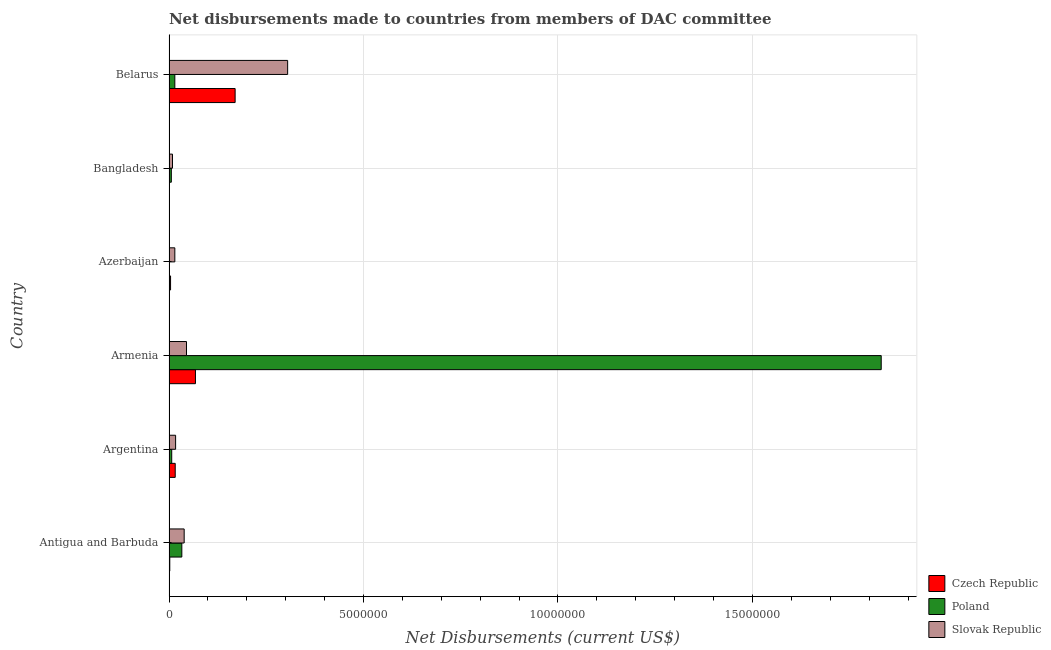Are the number of bars per tick equal to the number of legend labels?
Ensure brevity in your answer.  Yes. How many bars are there on the 6th tick from the top?
Ensure brevity in your answer.  3. How many bars are there on the 3rd tick from the bottom?
Make the answer very short. 3. What is the label of the 1st group of bars from the top?
Make the answer very short. Belarus. In how many cases, is the number of bars for a given country not equal to the number of legend labels?
Keep it short and to the point. 0. What is the net disbursements made by slovak republic in Belarus?
Provide a short and direct response. 3.05e+06. Across all countries, what is the maximum net disbursements made by slovak republic?
Your answer should be compact. 3.05e+06. Across all countries, what is the minimum net disbursements made by poland?
Offer a very short reply. 10000. In which country was the net disbursements made by poland maximum?
Your response must be concise. Armenia. In which country was the net disbursements made by slovak republic minimum?
Your response must be concise. Bangladesh. What is the total net disbursements made by czech republic in the graph?
Make the answer very short. 2.61e+06. What is the difference between the net disbursements made by poland in Bangladesh and that in Belarus?
Offer a terse response. -9.00e+04. What is the difference between the net disbursements made by poland in Antigua and Barbuda and the net disbursements made by czech republic in Armenia?
Your answer should be very brief. -3.50e+05. What is the average net disbursements made by czech republic per country?
Keep it short and to the point. 4.35e+05. What is the difference between the net disbursements made by czech republic and net disbursements made by slovak republic in Antigua and Barbuda?
Provide a short and direct response. -3.70e+05. In how many countries, is the net disbursements made by poland greater than 2000000 US$?
Offer a very short reply. 1. What is the ratio of the net disbursements made by poland in Azerbaijan to that in Belarus?
Provide a succinct answer. 0.07. Is the net disbursements made by czech republic in Antigua and Barbuda less than that in Bangladesh?
Give a very brief answer. No. Is the difference between the net disbursements made by poland in Argentina and Belarus greater than the difference between the net disbursements made by czech republic in Argentina and Belarus?
Make the answer very short. Yes. What is the difference between the highest and the second highest net disbursements made by czech republic?
Provide a short and direct response. 1.02e+06. What is the difference between the highest and the lowest net disbursements made by slovak republic?
Offer a very short reply. 2.96e+06. Is the sum of the net disbursements made by slovak republic in Antigua and Barbuda and Azerbaijan greater than the maximum net disbursements made by poland across all countries?
Make the answer very short. No. What does the 3rd bar from the bottom in Azerbaijan represents?
Make the answer very short. Slovak Republic. Is it the case that in every country, the sum of the net disbursements made by czech republic and net disbursements made by poland is greater than the net disbursements made by slovak republic?
Ensure brevity in your answer.  No. How many bars are there?
Keep it short and to the point. 18. Are the values on the major ticks of X-axis written in scientific E-notation?
Provide a short and direct response. No. Does the graph contain any zero values?
Your answer should be very brief. No. Does the graph contain grids?
Provide a succinct answer. Yes. Where does the legend appear in the graph?
Ensure brevity in your answer.  Bottom right. What is the title of the graph?
Make the answer very short. Net disbursements made to countries from members of DAC committee. What is the label or title of the X-axis?
Provide a short and direct response. Net Disbursements (current US$). What is the Net Disbursements (current US$) of Czech Republic in Antigua and Barbuda?
Give a very brief answer. 2.00e+04. What is the Net Disbursements (current US$) of Poland in Antigua and Barbuda?
Ensure brevity in your answer.  3.30e+05. What is the Net Disbursements (current US$) of Slovak Republic in Argentina?
Make the answer very short. 1.70e+05. What is the Net Disbursements (current US$) in Czech Republic in Armenia?
Your answer should be very brief. 6.80e+05. What is the Net Disbursements (current US$) of Poland in Armenia?
Your answer should be compact. 1.83e+07. What is the Net Disbursements (current US$) in Poland in Azerbaijan?
Offer a terse response. 10000. What is the Net Disbursements (current US$) of Czech Republic in Bangladesh?
Your answer should be compact. 10000. What is the Net Disbursements (current US$) in Poland in Bangladesh?
Offer a very short reply. 6.00e+04. What is the Net Disbursements (current US$) of Czech Republic in Belarus?
Your answer should be very brief. 1.70e+06. What is the Net Disbursements (current US$) in Slovak Republic in Belarus?
Make the answer very short. 3.05e+06. Across all countries, what is the maximum Net Disbursements (current US$) of Czech Republic?
Provide a succinct answer. 1.70e+06. Across all countries, what is the maximum Net Disbursements (current US$) in Poland?
Provide a succinct answer. 1.83e+07. Across all countries, what is the maximum Net Disbursements (current US$) of Slovak Republic?
Your answer should be compact. 3.05e+06. Across all countries, what is the minimum Net Disbursements (current US$) in Poland?
Your response must be concise. 10000. What is the total Net Disbursements (current US$) of Czech Republic in the graph?
Provide a succinct answer. 2.61e+06. What is the total Net Disbursements (current US$) of Poland in the graph?
Offer a terse response. 1.89e+07. What is the total Net Disbursements (current US$) of Slovak Republic in the graph?
Your answer should be very brief. 4.30e+06. What is the difference between the Net Disbursements (current US$) of Czech Republic in Antigua and Barbuda and that in Argentina?
Your answer should be compact. -1.40e+05. What is the difference between the Net Disbursements (current US$) of Poland in Antigua and Barbuda and that in Argentina?
Offer a very short reply. 2.60e+05. What is the difference between the Net Disbursements (current US$) of Czech Republic in Antigua and Barbuda and that in Armenia?
Offer a terse response. -6.60e+05. What is the difference between the Net Disbursements (current US$) of Poland in Antigua and Barbuda and that in Armenia?
Your answer should be compact. -1.80e+07. What is the difference between the Net Disbursements (current US$) of Slovak Republic in Antigua and Barbuda and that in Armenia?
Provide a succinct answer. -6.00e+04. What is the difference between the Net Disbursements (current US$) in Czech Republic in Antigua and Barbuda and that in Azerbaijan?
Your answer should be compact. -2.00e+04. What is the difference between the Net Disbursements (current US$) in Czech Republic in Antigua and Barbuda and that in Bangladesh?
Keep it short and to the point. 10000. What is the difference between the Net Disbursements (current US$) of Slovak Republic in Antigua and Barbuda and that in Bangladesh?
Provide a short and direct response. 3.00e+05. What is the difference between the Net Disbursements (current US$) of Czech Republic in Antigua and Barbuda and that in Belarus?
Ensure brevity in your answer.  -1.68e+06. What is the difference between the Net Disbursements (current US$) of Poland in Antigua and Barbuda and that in Belarus?
Give a very brief answer. 1.80e+05. What is the difference between the Net Disbursements (current US$) in Slovak Republic in Antigua and Barbuda and that in Belarus?
Your answer should be very brief. -2.66e+06. What is the difference between the Net Disbursements (current US$) in Czech Republic in Argentina and that in Armenia?
Your answer should be compact. -5.20e+05. What is the difference between the Net Disbursements (current US$) in Poland in Argentina and that in Armenia?
Your response must be concise. -1.82e+07. What is the difference between the Net Disbursements (current US$) of Slovak Republic in Argentina and that in Armenia?
Provide a short and direct response. -2.80e+05. What is the difference between the Net Disbursements (current US$) of Czech Republic in Argentina and that in Azerbaijan?
Ensure brevity in your answer.  1.20e+05. What is the difference between the Net Disbursements (current US$) in Poland in Argentina and that in Azerbaijan?
Provide a short and direct response. 6.00e+04. What is the difference between the Net Disbursements (current US$) in Slovak Republic in Argentina and that in Azerbaijan?
Offer a terse response. 2.00e+04. What is the difference between the Net Disbursements (current US$) in Slovak Republic in Argentina and that in Bangladesh?
Offer a terse response. 8.00e+04. What is the difference between the Net Disbursements (current US$) of Czech Republic in Argentina and that in Belarus?
Provide a succinct answer. -1.54e+06. What is the difference between the Net Disbursements (current US$) in Poland in Argentina and that in Belarus?
Provide a succinct answer. -8.00e+04. What is the difference between the Net Disbursements (current US$) in Slovak Republic in Argentina and that in Belarus?
Make the answer very short. -2.88e+06. What is the difference between the Net Disbursements (current US$) in Czech Republic in Armenia and that in Azerbaijan?
Give a very brief answer. 6.40e+05. What is the difference between the Net Disbursements (current US$) in Poland in Armenia and that in Azerbaijan?
Provide a short and direct response. 1.83e+07. What is the difference between the Net Disbursements (current US$) in Czech Republic in Armenia and that in Bangladesh?
Ensure brevity in your answer.  6.70e+05. What is the difference between the Net Disbursements (current US$) in Poland in Armenia and that in Bangladesh?
Your answer should be very brief. 1.82e+07. What is the difference between the Net Disbursements (current US$) of Czech Republic in Armenia and that in Belarus?
Keep it short and to the point. -1.02e+06. What is the difference between the Net Disbursements (current US$) of Poland in Armenia and that in Belarus?
Provide a short and direct response. 1.82e+07. What is the difference between the Net Disbursements (current US$) of Slovak Republic in Armenia and that in Belarus?
Provide a short and direct response. -2.60e+06. What is the difference between the Net Disbursements (current US$) in Slovak Republic in Azerbaijan and that in Bangladesh?
Your response must be concise. 6.00e+04. What is the difference between the Net Disbursements (current US$) in Czech Republic in Azerbaijan and that in Belarus?
Offer a terse response. -1.66e+06. What is the difference between the Net Disbursements (current US$) of Poland in Azerbaijan and that in Belarus?
Offer a very short reply. -1.40e+05. What is the difference between the Net Disbursements (current US$) in Slovak Republic in Azerbaijan and that in Belarus?
Your answer should be compact. -2.90e+06. What is the difference between the Net Disbursements (current US$) in Czech Republic in Bangladesh and that in Belarus?
Keep it short and to the point. -1.69e+06. What is the difference between the Net Disbursements (current US$) of Slovak Republic in Bangladesh and that in Belarus?
Provide a succinct answer. -2.96e+06. What is the difference between the Net Disbursements (current US$) of Czech Republic in Antigua and Barbuda and the Net Disbursements (current US$) of Poland in Armenia?
Provide a succinct answer. -1.83e+07. What is the difference between the Net Disbursements (current US$) of Czech Republic in Antigua and Barbuda and the Net Disbursements (current US$) of Slovak Republic in Armenia?
Ensure brevity in your answer.  -4.30e+05. What is the difference between the Net Disbursements (current US$) of Poland in Antigua and Barbuda and the Net Disbursements (current US$) of Slovak Republic in Armenia?
Your response must be concise. -1.20e+05. What is the difference between the Net Disbursements (current US$) of Czech Republic in Antigua and Barbuda and the Net Disbursements (current US$) of Poland in Azerbaijan?
Make the answer very short. 10000. What is the difference between the Net Disbursements (current US$) in Czech Republic in Antigua and Barbuda and the Net Disbursements (current US$) in Slovak Republic in Azerbaijan?
Keep it short and to the point. -1.30e+05. What is the difference between the Net Disbursements (current US$) in Czech Republic in Antigua and Barbuda and the Net Disbursements (current US$) in Slovak Republic in Belarus?
Provide a short and direct response. -3.03e+06. What is the difference between the Net Disbursements (current US$) of Poland in Antigua and Barbuda and the Net Disbursements (current US$) of Slovak Republic in Belarus?
Your answer should be compact. -2.72e+06. What is the difference between the Net Disbursements (current US$) of Czech Republic in Argentina and the Net Disbursements (current US$) of Poland in Armenia?
Your response must be concise. -1.82e+07. What is the difference between the Net Disbursements (current US$) in Poland in Argentina and the Net Disbursements (current US$) in Slovak Republic in Armenia?
Offer a very short reply. -3.80e+05. What is the difference between the Net Disbursements (current US$) of Czech Republic in Argentina and the Net Disbursements (current US$) of Slovak Republic in Azerbaijan?
Your response must be concise. 10000. What is the difference between the Net Disbursements (current US$) of Poland in Argentina and the Net Disbursements (current US$) of Slovak Republic in Azerbaijan?
Give a very brief answer. -8.00e+04. What is the difference between the Net Disbursements (current US$) in Czech Republic in Argentina and the Net Disbursements (current US$) in Poland in Bangladesh?
Provide a succinct answer. 1.00e+05. What is the difference between the Net Disbursements (current US$) of Czech Republic in Argentina and the Net Disbursements (current US$) of Slovak Republic in Bangladesh?
Provide a succinct answer. 7.00e+04. What is the difference between the Net Disbursements (current US$) in Czech Republic in Argentina and the Net Disbursements (current US$) in Slovak Republic in Belarus?
Ensure brevity in your answer.  -2.89e+06. What is the difference between the Net Disbursements (current US$) in Poland in Argentina and the Net Disbursements (current US$) in Slovak Republic in Belarus?
Ensure brevity in your answer.  -2.98e+06. What is the difference between the Net Disbursements (current US$) in Czech Republic in Armenia and the Net Disbursements (current US$) in Poland in Azerbaijan?
Provide a succinct answer. 6.70e+05. What is the difference between the Net Disbursements (current US$) in Czech Republic in Armenia and the Net Disbursements (current US$) in Slovak Republic in Azerbaijan?
Your answer should be compact. 5.30e+05. What is the difference between the Net Disbursements (current US$) of Poland in Armenia and the Net Disbursements (current US$) of Slovak Republic in Azerbaijan?
Offer a terse response. 1.82e+07. What is the difference between the Net Disbursements (current US$) in Czech Republic in Armenia and the Net Disbursements (current US$) in Poland in Bangladesh?
Make the answer very short. 6.20e+05. What is the difference between the Net Disbursements (current US$) in Czech Republic in Armenia and the Net Disbursements (current US$) in Slovak Republic in Bangladesh?
Provide a short and direct response. 5.90e+05. What is the difference between the Net Disbursements (current US$) in Poland in Armenia and the Net Disbursements (current US$) in Slovak Republic in Bangladesh?
Your response must be concise. 1.82e+07. What is the difference between the Net Disbursements (current US$) in Czech Republic in Armenia and the Net Disbursements (current US$) in Poland in Belarus?
Give a very brief answer. 5.30e+05. What is the difference between the Net Disbursements (current US$) of Czech Republic in Armenia and the Net Disbursements (current US$) of Slovak Republic in Belarus?
Ensure brevity in your answer.  -2.37e+06. What is the difference between the Net Disbursements (current US$) of Poland in Armenia and the Net Disbursements (current US$) of Slovak Republic in Belarus?
Your response must be concise. 1.53e+07. What is the difference between the Net Disbursements (current US$) of Czech Republic in Azerbaijan and the Net Disbursements (current US$) of Slovak Republic in Bangladesh?
Your answer should be compact. -5.00e+04. What is the difference between the Net Disbursements (current US$) in Poland in Azerbaijan and the Net Disbursements (current US$) in Slovak Republic in Bangladesh?
Provide a short and direct response. -8.00e+04. What is the difference between the Net Disbursements (current US$) of Czech Republic in Azerbaijan and the Net Disbursements (current US$) of Slovak Republic in Belarus?
Your response must be concise. -3.01e+06. What is the difference between the Net Disbursements (current US$) of Poland in Azerbaijan and the Net Disbursements (current US$) of Slovak Republic in Belarus?
Ensure brevity in your answer.  -3.04e+06. What is the difference between the Net Disbursements (current US$) of Czech Republic in Bangladesh and the Net Disbursements (current US$) of Poland in Belarus?
Offer a terse response. -1.40e+05. What is the difference between the Net Disbursements (current US$) in Czech Republic in Bangladesh and the Net Disbursements (current US$) in Slovak Republic in Belarus?
Offer a very short reply. -3.04e+06. What is the difference between the Net Disbursements (current US$) in Poland in Bangladesh and the Net Disbursements (current US$) in Slovak Republic in Belarus?
Provide a short and direct response. -2.99e+06. What is the average Net Disbursements (current US$) of Czech Republic per country?
Your answer should be compact. 4.35e+05. What is the average Net Disbursements (current US$) of Poland per country?
Provide a succinct answer. 3.16e+06. What is the average Net Disbursements (current US$) in Slovak Republic per country?
Keep it short and to the point. 7.17e+05. What is the difference between the Net Disbursements (current US$) of Czech Republic and Net Disbursements (current US$) of Poland in Antigua and Barbuda?
Give a very brief answer. -3.10e+05. What is the difference between the Net Disbursements (current US$) in Czech Republic and Net Disbursements (current US$) in Slovak Republic in Antigua and Barbuda?
Provide a succinct answer. -3.70e+05. What is the difference between the Net Disbursements (current US$) in Poland and Net Disbursements (current US$) in Slovak Republic in Argentina?
Ensure brevity in your answer.  -1.00e+05. What is the difference between the Net Disbursements (current US$) of Czech Republic and Net Disbursements (current US$) of Poland in Armenia?
Your answer should be compact. -1.76e+07. What is the difference between the Net Disbursements (current US$) in Poland and Net Disbursements (current US$) in Slovak Republic in Armenia?
Your response must be concise. 1.79e+07. What is the difference between the Net Disbursements (current US$) of Czech Republic and Net Disbursements (current US$) of Poland in Azerbaijan?
Keep it short and to the point. 3.00e+04. What is the difference between the Net Disbursements (current US$) of Czech Republic and Net Disbursements (current US$) of Slovak Republic in Bangladesh?
Make the answer very short. -8.00e+04. What is the difference between the Net Disbursements (current US$) of Poland and Net Disbursements (current US$) of Slovak Republic in Bangladesh?
Offer a very short reply. -3.00e+04. What is the difference between the Net Disbursements (current US$) of Czech Republic and Net Disbursements (current US$) of Poland in Belarus?
Give a very brief answer. 1.55e+06. What is the difference between the Net Disbursements (current US$) of Czech Republic and Net Disbursements (current US$) of Slovak Republic in Belarus?
Keep it short and to the point. -1.35e+06. What is the difference between the Net Disbursements (current US$) of Poland and Net Disbursements (current US$) of Slovak Republic in Belarus?
Make the answer very short. -2.90e+06. What is the ratio of the Net Disbursements (current US$) of Poland in Antigua and Barbuda to that in Argentina?
Provide a succinct answer. 4.71. What is the ratio of the Net Disbursements (current US$) of Slovak Republic in Antigua and Barbuda to that in Argentina?
Keep it short and to the point. 2.29. What is the ratio of the Net Disbursements (current US$) in Czech Republic in Antigua and Barbuda to that in Armenia?
Provide a succinct answer. 0.03. What is the ratio of the Net Disbursements (current US$) of Poland in Antigua and Barbuda to that in Armenia?
Make the answer very short. 0.02. What is the ratio of the Net Disbursements (current US$) in Slovak Republic in Antigua and Barbuda to that in Armenia?
Provide a short and direct response. 0.87. What is the ratio of the Net Disbursements (current US$) in Poland in Antigua and Barbuda to that in Azerbaijan?
Give a very brief answer. 33. What is the ratio of the Net Disbursements (current US$) of Slovak Republic in Antigua and Barbuda to that in Bangladesh?
Your response must be concise. 4.33. What is the ratio of the Net Disbursements (current US$) in Czech Republic in Antigua and Barbuda to that in Belarus?
Provide a short and direct response. 0.01. What is the ratio of the Net Disbursements (current US$) in Slovak Republic in Antigua and Barbuda to that in Belarus?
Keep it short and to the point. 0.13. What is the ratio of the Net Disbursements (current US$) of Czech Republic in Argentina to that in Armenia?
Ensure brevity in your answer.  0.24. What is the ratio of the Net Disbursements (current US$) in Poland in Argentina to that in Armenia?
Ensure brevity in your answer.  0. What is the ratio of the Net Disbursements (current US$) of Slovak Republic in Argentina to that in Armenia?
Your response must be concise. 0.38. What is the ratio of the Net Disbursements (current US$) of Slovak Republic in Argentina to that in Azerbaijan?
Offer a very short reply. 1.13. What is the ratio of the Net Disbursements (current US$) in Slovak Republic in Argentina to that in Bangladesh?
Provide a succinct answer. 1.89. What is the ratio of the Net Disbursements (current US$) of Czech Republic in Argentina to that in Belarus?
Give a very brief answer. 0.09. What is the ratio of the Net Disbursements (current US$) in Poland in Argentina to that in Belarus?
Provide a succinct answer. 0.47. What is the ratio of the Net Disbursements (current US$) in Slovak Republic in Argentina to that in Belarus?
Your response must be concise. 0.06. What is the ratio of the Net Disbursements (current US$) of Czech Republic in Armenia to that in Azerbaijan?
Provide a short and direct response. 17. What is the ratio of the Net Disbursements (current US$) in Poland in Armenia to that in Azerbaijan?
Offer a terse response. 1831. What is the ratio of the Net Disbursements (current US$) of Slovak Republic in Armenia to that in Azerbaijan?
Give a very brief answer. 3. What is the ratio of the Net Disbursements (current US$) in Czech Republic in Armenia to that in Bangladesh?
Offer a very short reply. 68. What is the ratio of the Net Disbursements (current US$) of Poland in Armenia to that in Bangladesh?
Provide a short and direct response. 305.17. What is the ratio of the Net Disbursements (current US$) in Slovak Republic in Armenia to that in Bangladesh?
Offer a terse response. 5. What is the ratio of the Net Disbursements (current US$) in Poland in Armenia to that in Belarus?
Ensure brevity in your answer.  122.07. What is the ratio of the Net Disbursements (current US$) in Slovak Republic in Armenia to that in Belarus?
Keep it short and to the point. 0.15. What is the ratio of the Net Disbursements (current US$) of Czech Republic in Azerbaijan to that in Bangladesh?
Give a very brief answer. 4. What is the ratio of the Net Disbursements (current US$) of Poland in Azerbaijan to that in Bangladesh?
Keep it short and to the point. 0.17. What is the ratio of the Net Disbursements (current US$) in Slovak Republic in Azerbaijan to that in Bangladesh?
Your response must be concise. 1.67. What is the ratio of the Net Disbursements (current US$) in Czech Republic in Azerbaijan to that in Belarus?
Your response must be concise. 0.02. What is the ratio of the Net Disbursements (current US$) of Poland in Azerbaijan to that in Belarus?
Your answer should be very brief. 0.07. What is the ratio of the Net Disbursements (current US$) in Slovak Republic in Azerbaijan to that in Belarus?
Ensure brevity in your answer.  0.05. What is the ratio of the Net Disbursements (current US$) of Czech Republic in Bangladesh to that in Belarus?
Keep it short and to the point. 0.01. What is the ratio of the Net Disbursements (current US$) of Poland in Bangladesh to that in Belarus?
Give a very brief answer. 0.4. What is the ratio of the Net Disbursements (current US$) in Slovak Republic in Bangladesh to that in Belarus?
Your response must be concise. 0.03. What is the difference between the highest and the second highest Net Disbursements (current US$) in Czech Republic?
Your answer should be very brief. 1.02e+06. What is the difference between the highest and the second highest Net Disbursements (current US$) in Poland?
Ensure brevity in your answer.  1.80e+07. What is the difference between the highest and the second highest Net Disbursements (current US$) of Slovak Republic?
Keep it short and to the point. 2.60e+06. What is the difference between the highest and the lowest Net Disbursements (current US$) in Czech Republic?
Your answer should be compact. 1.69e+06. What is the difference between the highest and the lowest Net Disbursements (current US$) in Poland?
Ensure brevity in your answer.  1.83e+07. What is the difference between the highest and the lowest Net Disbursements (current US$) in Slovak Republic?
Provide a short and direct response. 2.96e+06. 